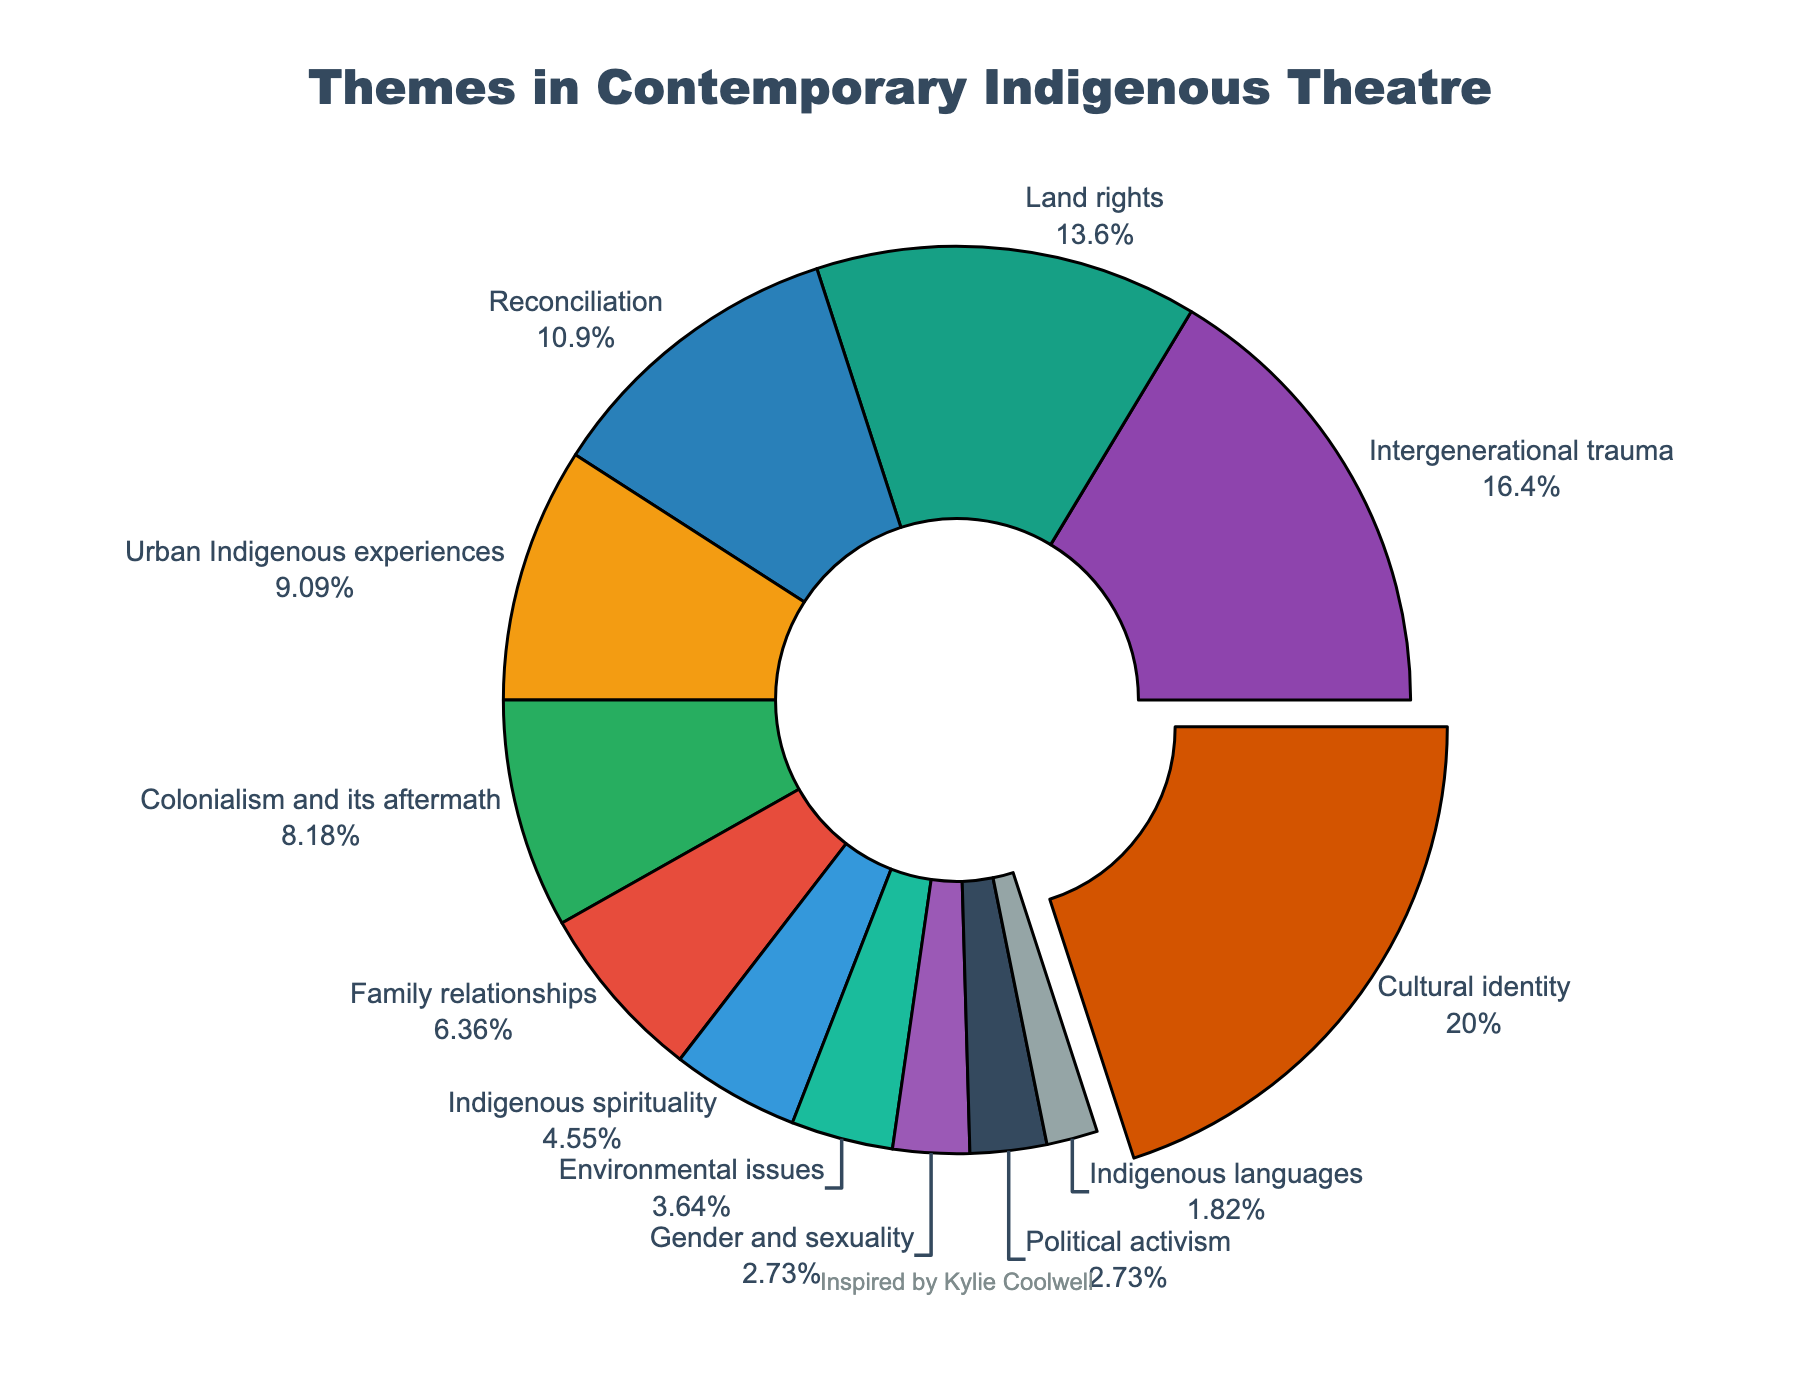Which theme is the most explored in contemporary Indigenous theatre? The pie chart shows that "Cultural identity" has the largest percentage. By visually inspecting the segments, "Cultural identity" is clearly larger than the other segments.
Answer: Cultural identity What percentage of themes are related to "Urban Indigenous experiences" compared to "Family relationships"? The chart shows that "Urban Indigenous experiences" is at 10% and "Family relationships" is at 7%. By subtracting, 10% - 7% = 3%.
Answer: 3% How much more percentage does "Cultural identity" have compared to "Gender and sexuality"? "Cultural identity" accounts for 22% and "Gender and sexuality" for 3%. The difference is calculated as 22% - 3% = 19%.
Answer: 19% If "Political activism" and "Reconciliation" themes were combined, what would be their total percentage? "Political activism" is at 3% and "Reconciliation" is at 12%. Their combined percentage is 3% + 12% = 15%.
Answer: 15% Which theme has the smallest representation? By observing the pie chart, "Indigenous languages" has the smallest segment with 2%.
Answer: Indigenous languages By how much does "Intergenerational trauma" exceed "Land rights" in terms of percentage? "Intergenerational trauma" stands at 18% while "Land rights" is at 15%. The excess percentage is 18% - 15% = 3%.
Answer: 3% How much percentage is covered collectively by the themes "Environmental issues" and "Gender and sexuality"? "Environmental issues" account for 4% and "Gender and sexuality" for 3%. Their total is 4% + 3% = 7%.
Answer: 7% Which theme covers a larger percentage: "Colonialism and its aftermath" or "Indigenous spirituality"? "Colonialism and its aftermath" stands at 9%, whereas "Indigenous spirituality" is at 5%. Thus, "Colonialism and its aftermath" covers a larger percentage.
Answer: Colonialism and its aftermath What is the combined percentage of the three least explored themes? The least explored themes are "Political activism" (3%), "Gender and sexuality" (3%), and "Indigenous languages" (2%). Their combined percentage is 3% + 3% + 2% = 8%.
Answer: 8% What is the ratio of "Reconciliation" to "Family relationships"? "Reconciliation" has a percentage of 12%, and "Family relationships" has 7%. The ratio of "Reconciliation" to "Family relationships" is 12:7.
Answer: 12:7 